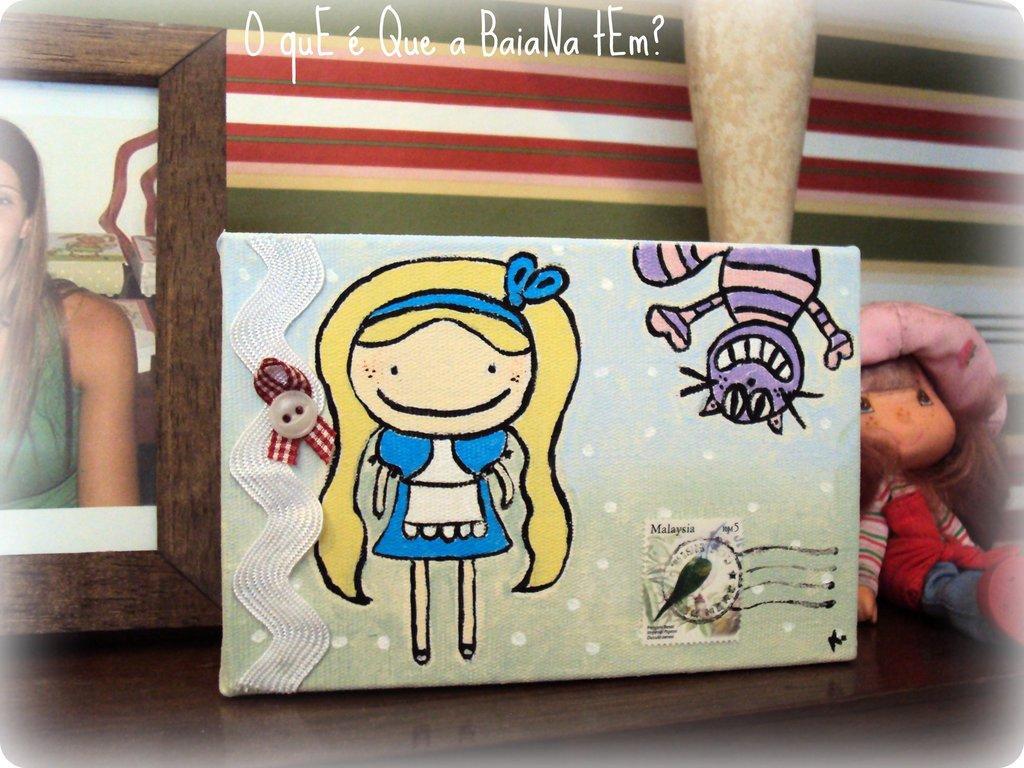Can you describe this image briefly? In this picture I can see an envelope in front, on which I can the pictures of cartoon characters and I see a stamp. On the left side of this picture I can see a photo frame and on the photo I can see a woman. On the right of this picture I can see a soft toy. On the top of this picture I can see the watermark. 